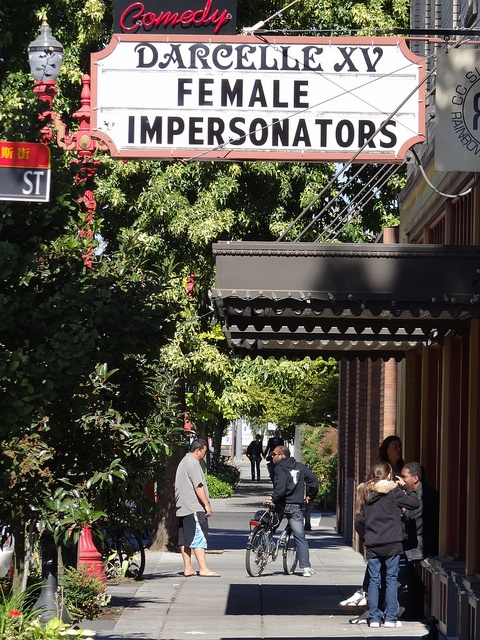Describe the objects in this image and their specific colors. I can see people in black and gray tones, people in black, lightgray, darkgray, and tan tones, people in black, gray, and darkgray tones, bicycle in black, gray, and darkgray tones, and people in black, gray, white, and brown tones in this image. 